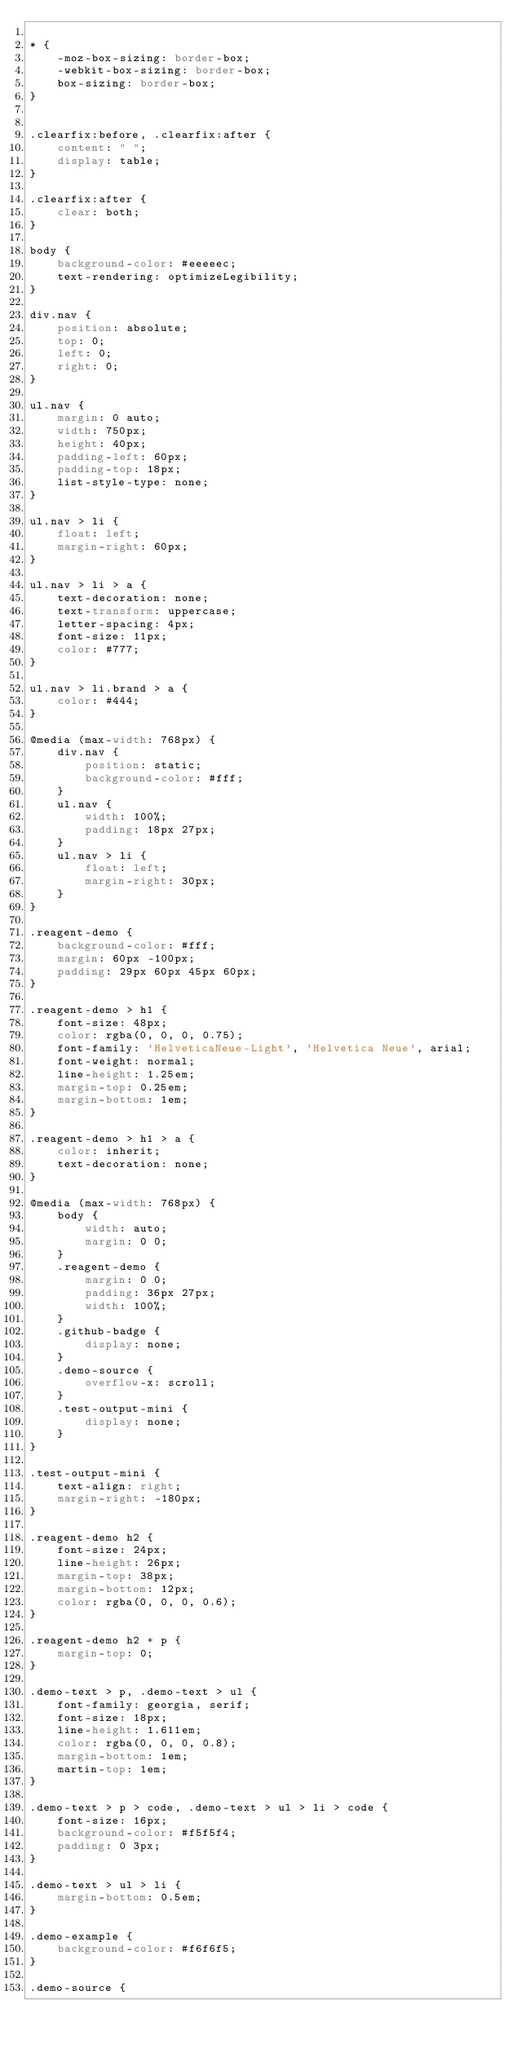<code> <loc_0><loc_0><loc_500><loc_500><_CSS_>
* { 
    -moz-box-sizing: border-box;
    -webkit-box-sizing: border-box;
    box-sizing: border-box;
}


.clearfix:before, .clearfix:after {
    content: " ";
    display: table;
}

.clearfix:after {
    clear: both;
}

body {
    background-color: #eeeeec;
    text-rendering: optimizeLegibility;
}

div.nav {
    position: absolute;
    top: 0;
    left: 0;
    right: 0;
}

ul.nav {
    margin: 0 auto;
    width: 750px;
    height: 40px;
    padding-left: 60px;
    padding-top: 18px;
    list-style-type: none;
}

ul.nav > li {
    float: left;
    margin-right: 60px;
}

ul.nav > li > a {
    text-decoration: none;
    text-transform: uppercase;
    letter-spacing: 4px;
    font-size: 11px;
    color: #777;
}

ul.nav > li.brand > a {
    color: #444;
}

@media (max-width: 768px) {
    div.nav {
        position: static;
        background-color: #fff;
    }
    ul.nav {
        width: 100%;
        padding: 18px 27px;
    }
    ul.nav > li {
        float: left;
        margin-right: 30px;
    }
}

.reagent-demo {
    background-color: #fff;
    margin: 60px -100px;
    padding: 29px 60px 45px 60px;
}

.reagent-demo > h1 {
    font-size: 48px;
    color: rgba(0, 0, 0, 0.75);
    font-family: 'HelveticaNeue-Light', 'Helvetica Neue', arial;
    font-weight: normal;
    line-height: 1.25em;
    margin-top: 0.25em;
    margin-bottom: 1em;
}

.reagent-demo > h1 > a {
    color: inherit;
    text-decoration: none;
}

@media (max-width: 768px) {
    body {
        width: auto;
        margin: 0 0;
    }
    .reagent-demo {
        margin: 0 0;
        padding: 36px 27px;
        width: 100%;
    }
    .github-badge {
        display: none;
    }
    .demo-source {
        overflow-x: scroll;
    }
    .test-output-mini {
        display: none;
    }
}

.test-output-mini {
    text-align: right;
    margin-right: -180px;
}

.reagent-demo h2 {
    font-size: 24px;
    line-height: 26px;
    margin-top: 38px;
    margin-bottom: 12px;
    color: rgba(0, 0, 0, 0.6);
}

.reagent-demo h2 + p {
    margin-top: 0;
}

.demo-text > p, .demo-text > ul {
    font-family: georgia, serif;
    font-size: 18px;
    line-height: 1.611em;
    color: rgba(0, 0, 0, 0.8);
    margin-bottom: 1em;
    martin-top: 1em;
}

.demo-text > p > code, .demo-text > ul > li > code {
    font-size: 16px;
    background-color: #f5f5f4;
    padding: 0 3px;
}

.demo-text > ul > li {
    margin-bottom: 0.5em;
}

.demo-example {
    background-color: #f6f6f5;
}

.demo-source {</code> 